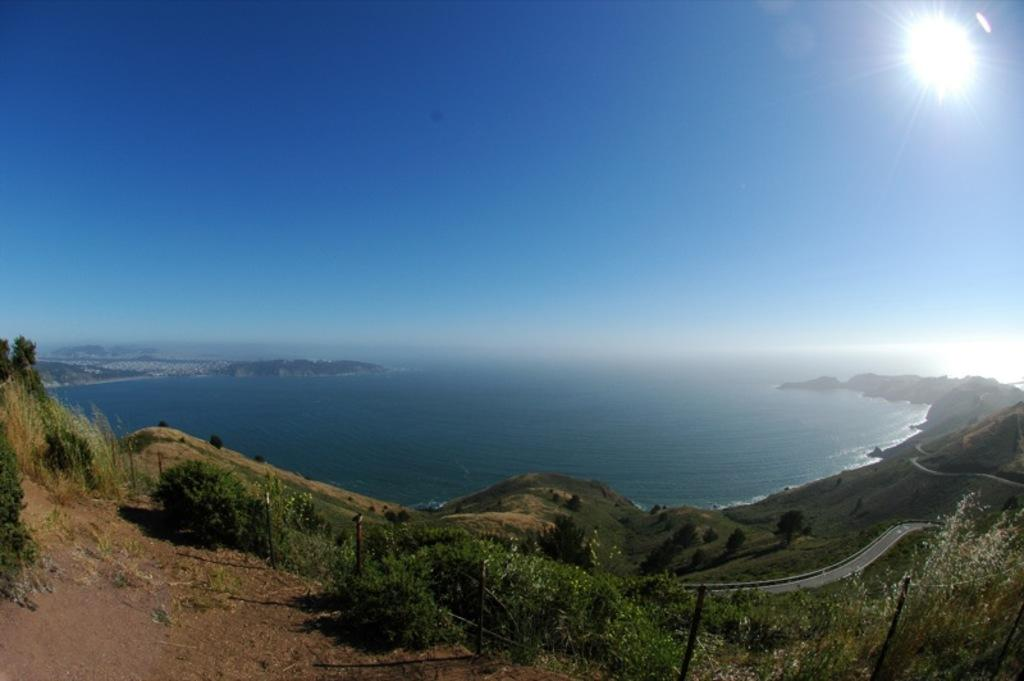What is the main subject of the image? The main subject of the image is an ocean. Are there any other elements present at the bottom of the image? Yes, there are plants on the ground at the bottom of the image. What color is the sky in the image? The sky is visible in blue color at the top of the image. How many snakes can be seen crawling on the bed in the image? There are no snakes or beds present in the image; it features an ocean, plants, and a blue sky. 